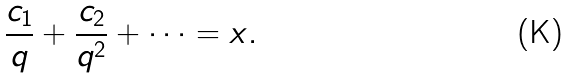<formula> <loc_0><loc_0><loc_500><loc_500>\frac { c _ { 1 } } { q } + \frac { c _ { 2 } } { q ^ { 2 } } + \cdots = x .</formula> 